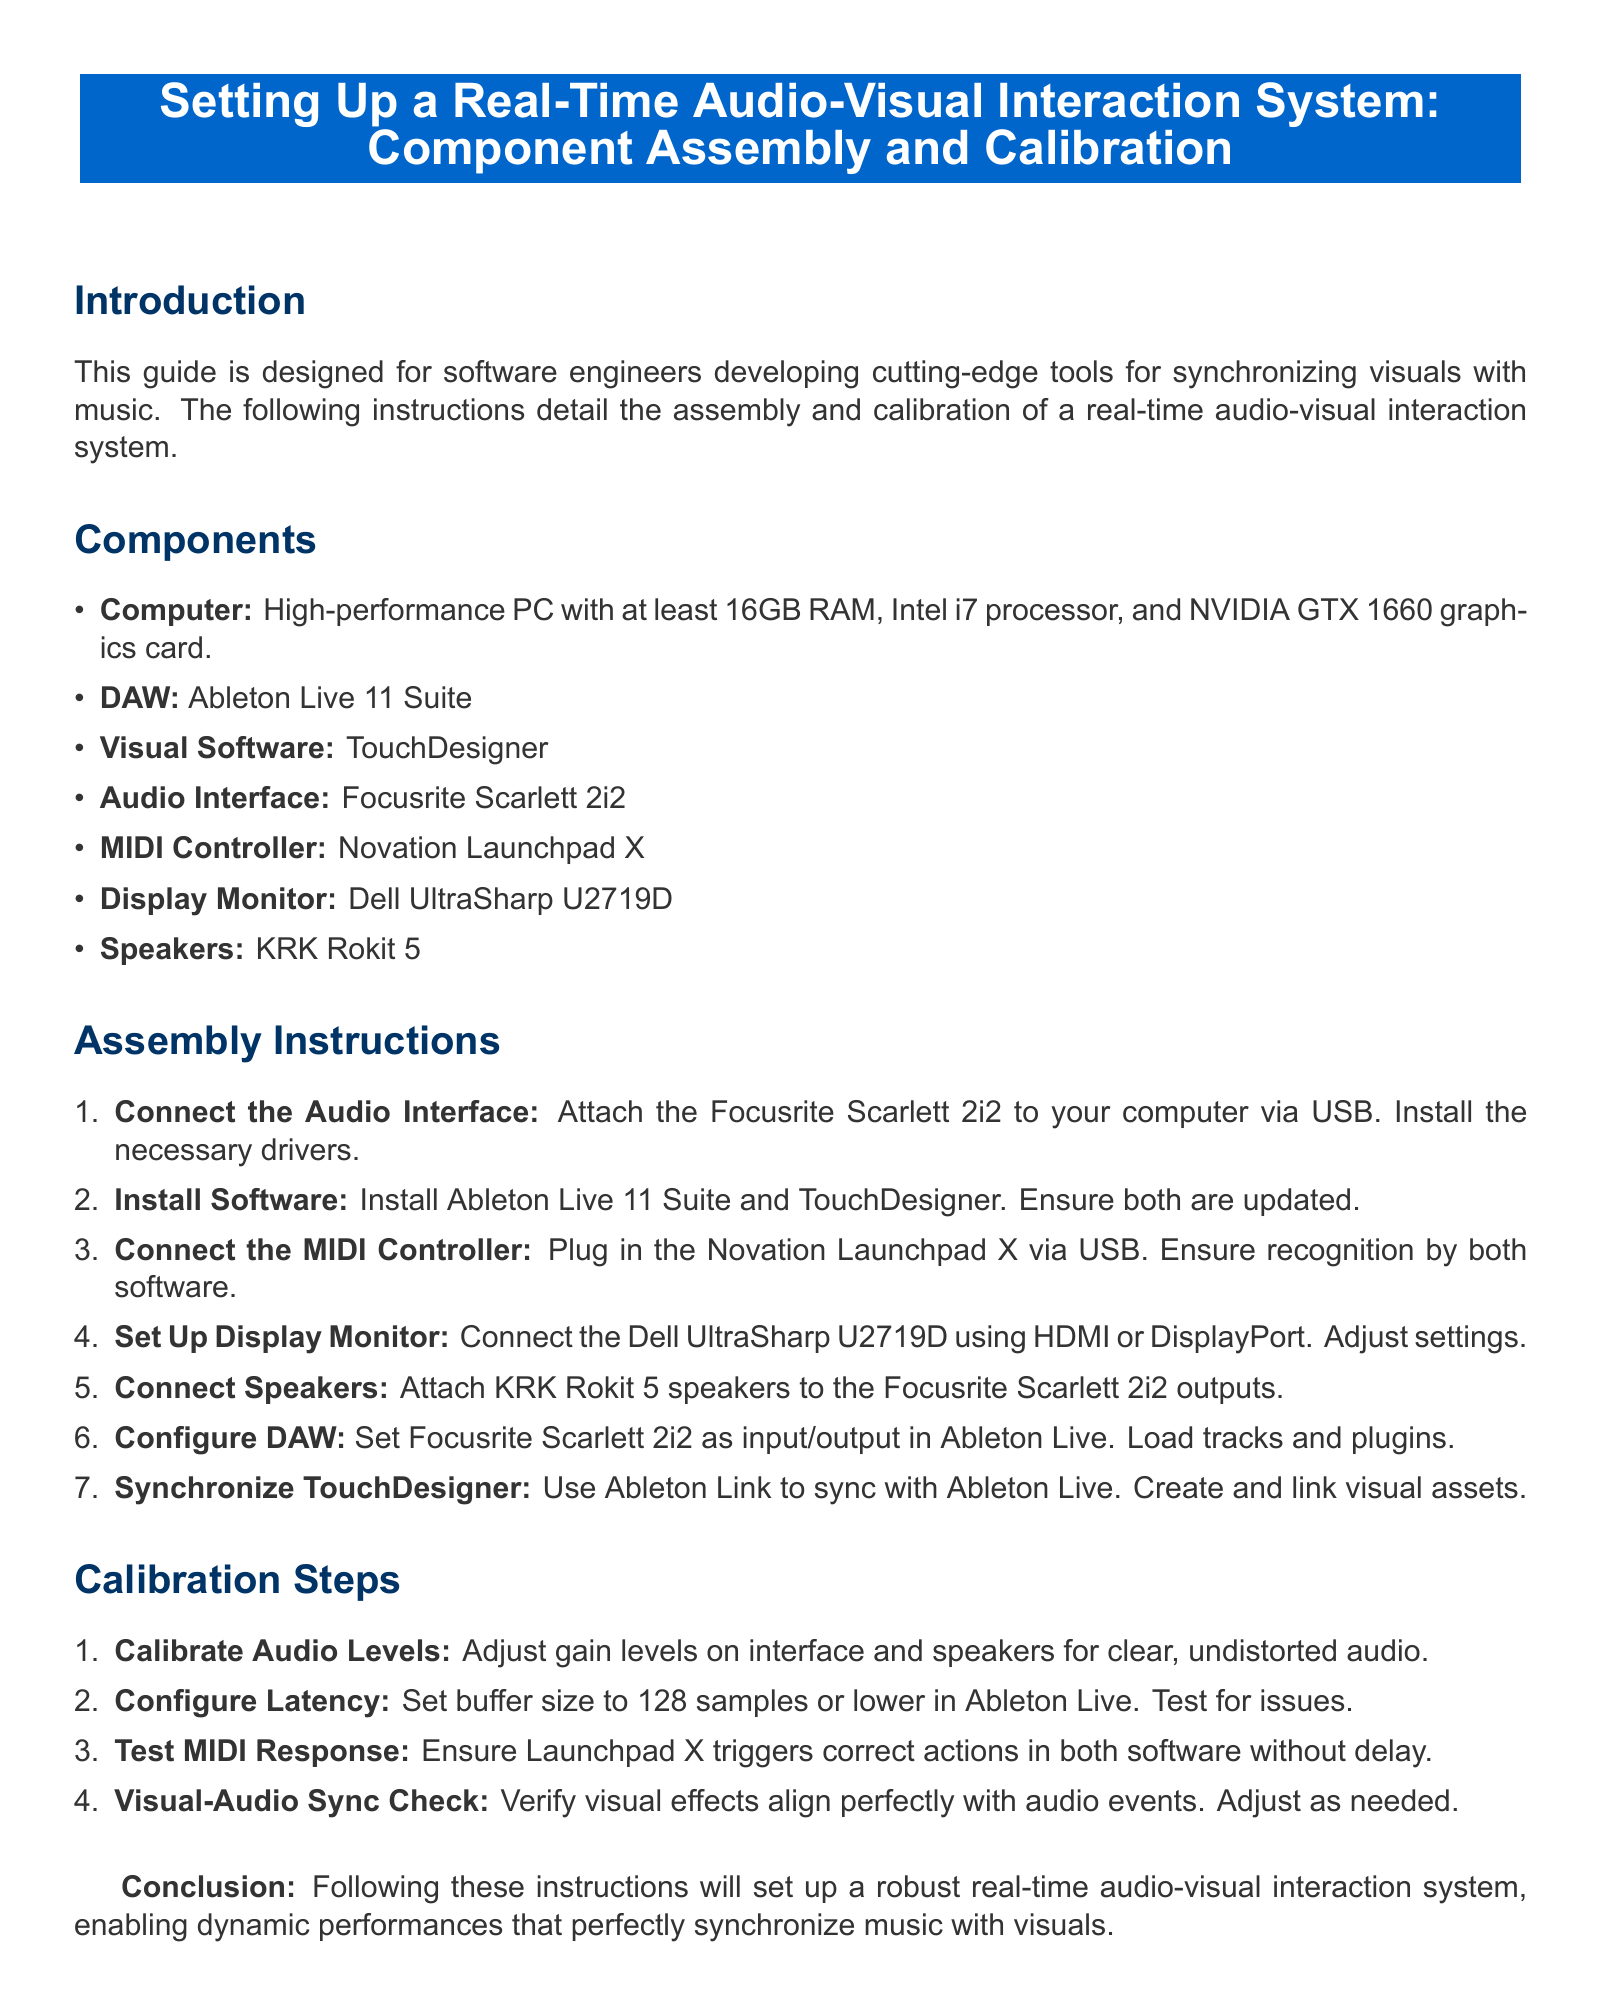What is the minimum RAM requirement? The document states that the computer must have at least 16GB RAM for the audio-visual system setup.
Answer: 16GB RAM Which audio interface is recommended? The document lists the Focusrite Scarlett 2i2 as the audio interface to be used in the setup.
Answer: Focusrite Scarlett 2i2 How should the speakers be connected? The document instructs to attach KRK Rokit 5 speakers to the outputs of the Focusrite Scarlett 2i2.
Answer: Outputs of the Focusrite Scarlett 2i2 What is the buffer size recommendation? The document advises setting the buffer size to 128 samples or lower to reduce latency.
Answer: 128 samples Which software is used for visuals? TouchDesigner is specified as the visual software to be installed in the system.
Answer: TouchDesigner What is the main focus of this guide? The purpose of the guide is to assist software engineers in synchronizing visuals with music through setup instructions.
Answer: Synchronizing visuals with music What should be done before connecting the MIDI controller? The document recommends that software recognition must be ensured for proper system functionality once connected.
Answer: Ensure recognition by both software How to verify visual-audio synchronization? The document instructs to check that visual effects align perfectly with audio events and adjust if necessary.
Answer: Visual effects align with audio events What type of document is this? This is an assembly instruction document providing detailed guidelines for setting up an audio-visual interaction system.
Answer: Assembly instructions 